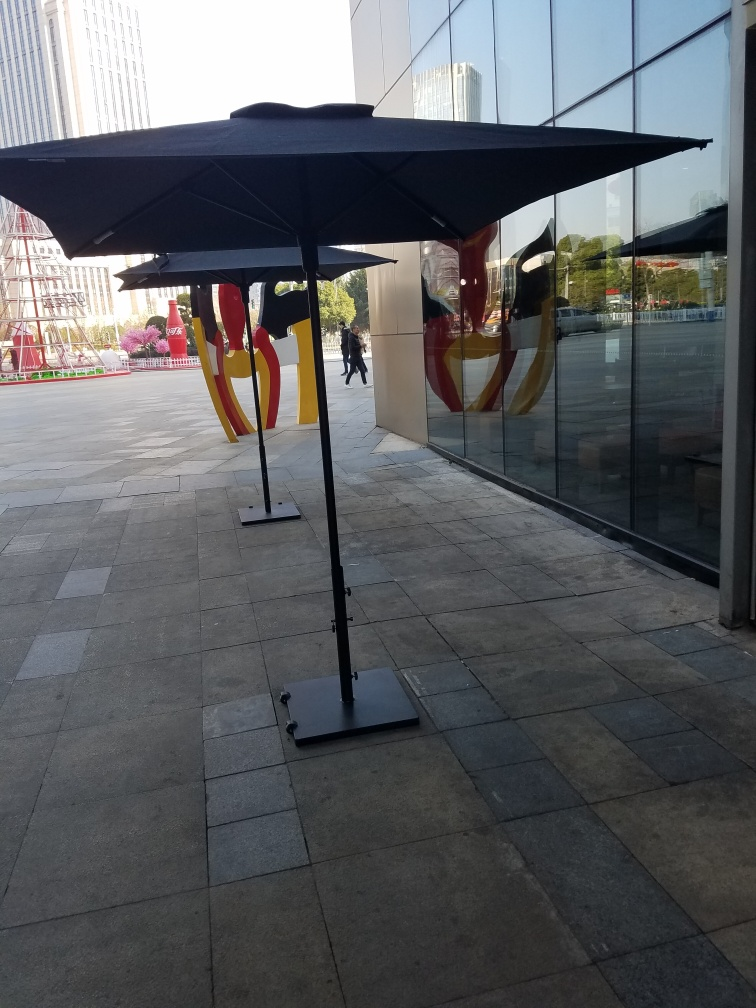Is there any sign of human activity in the image, and what does it suggest about the location? There is minimal human activity visible in the image; a single person can be seen in the distance which suggests the photo was taken at a time or day when foot traffic is low. This, coupled with the professional setting of the buildings, may imply that the location is a business district during non-peak hours, likely early morning or late evening. 